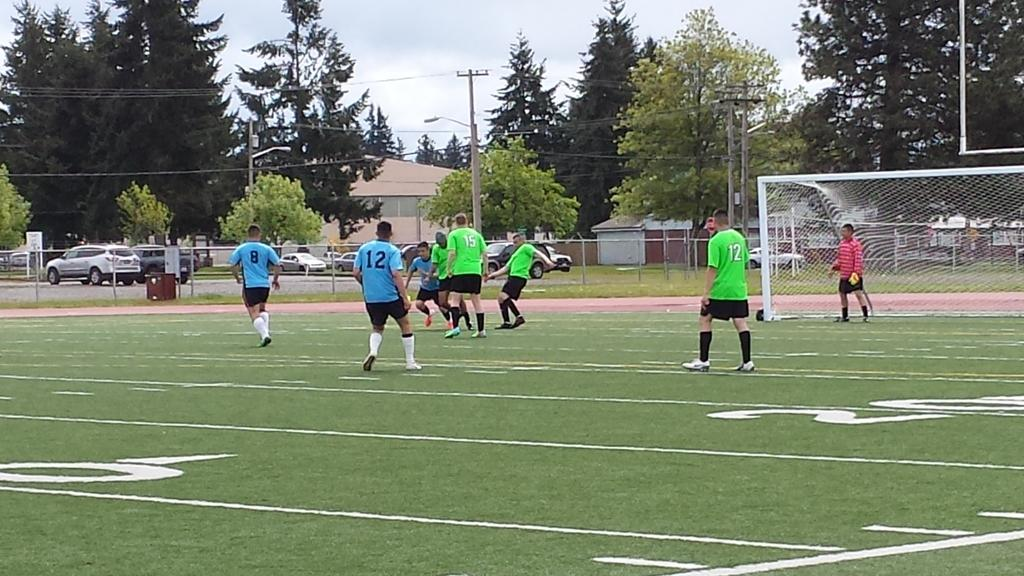<image>
Present a compact description of the photo's key features. soccer players on a field with one wearing the number 12 jersey 